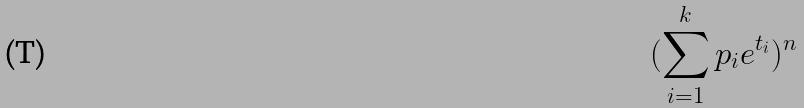<formula> <loc_0><loc_0><loc_500><loc_500>( \sum _ { i = 1 } ^ { k } p _ { i } e ^ { t _ { i } } ) ^ { n }</formula> 